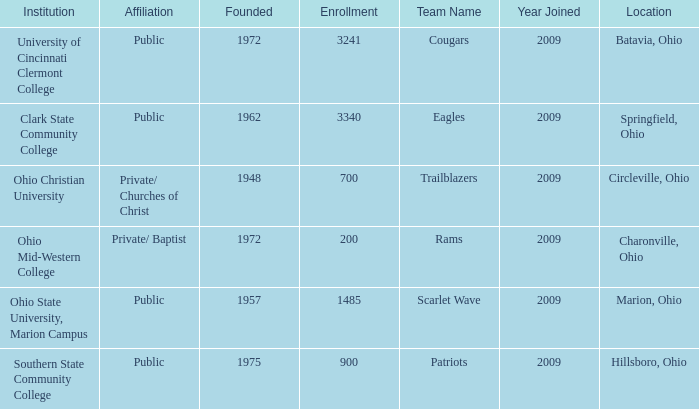What was the location for the team name of patriots? Hillsboro, Ohio. 